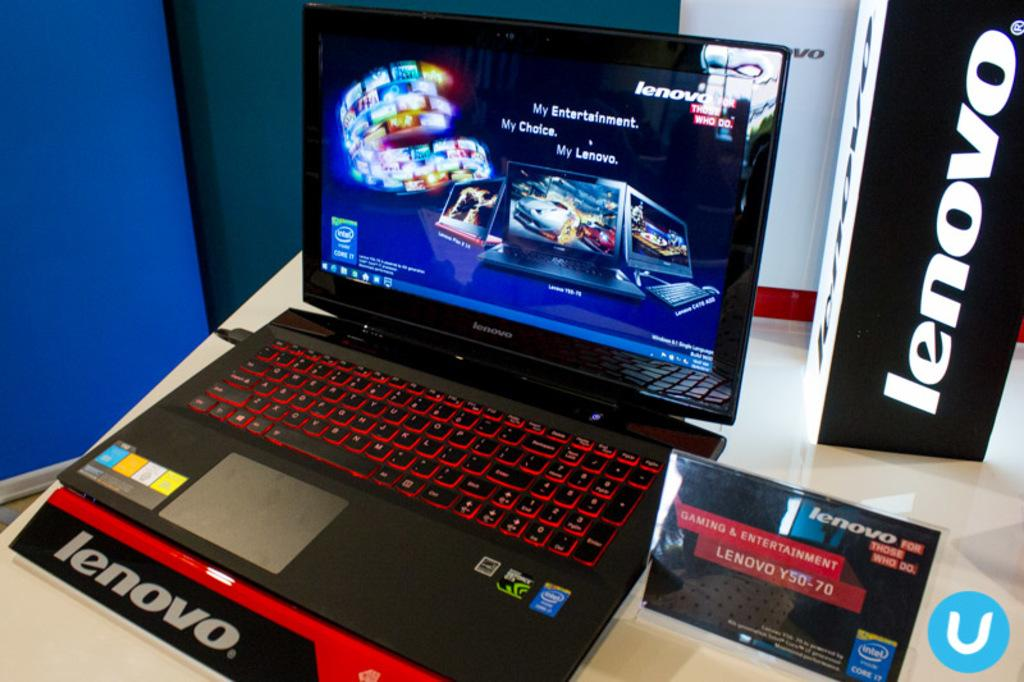<image>
Give a short and clear explanation of the subsequent image. A black Lenovo laptop and a brochure are on a table. 